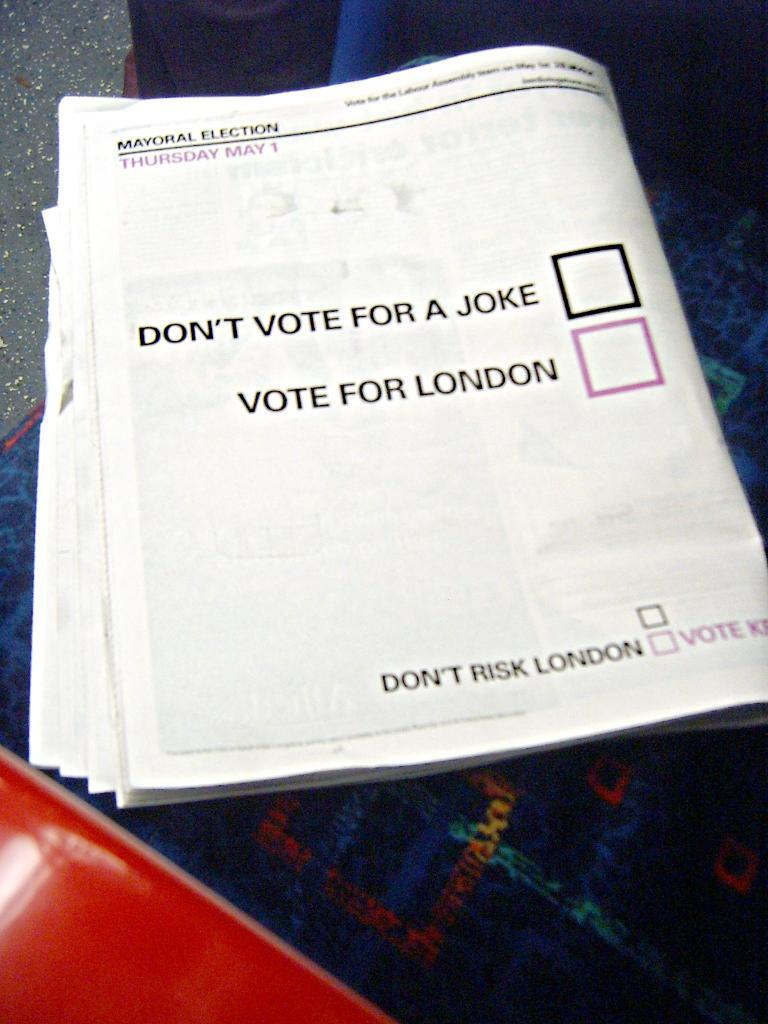<image>
Relay a brief, clear account of the picture shown. Booklet that says the words "Don't Risk London" on the bottom. 